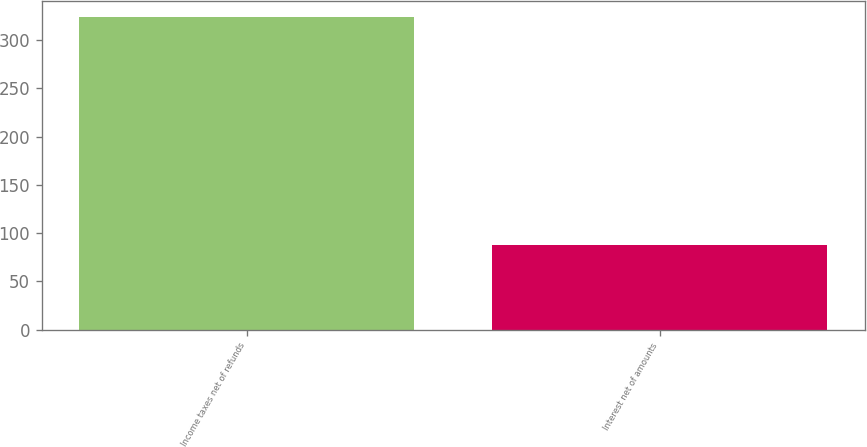Convert chart. <chart><loc_0><loc_0><loc_500><loc_500><bar_chart><fcel>Income taxes net of refunds<fcel>Interest net of amounts<nl><fcel>324<fcel>88<nl></chart> 